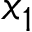<formula> <loc_0><loc_0><loc_500><loc_500>x _ { 1 }</formula> 